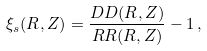<formula> <loc_0><loc_0><loc_500><loc_500>\xi _ { s } ( R , Z ) = \frac { D D ( R , Z ) } { R R ( R , Z ) } - 1 \, ,</formula> 